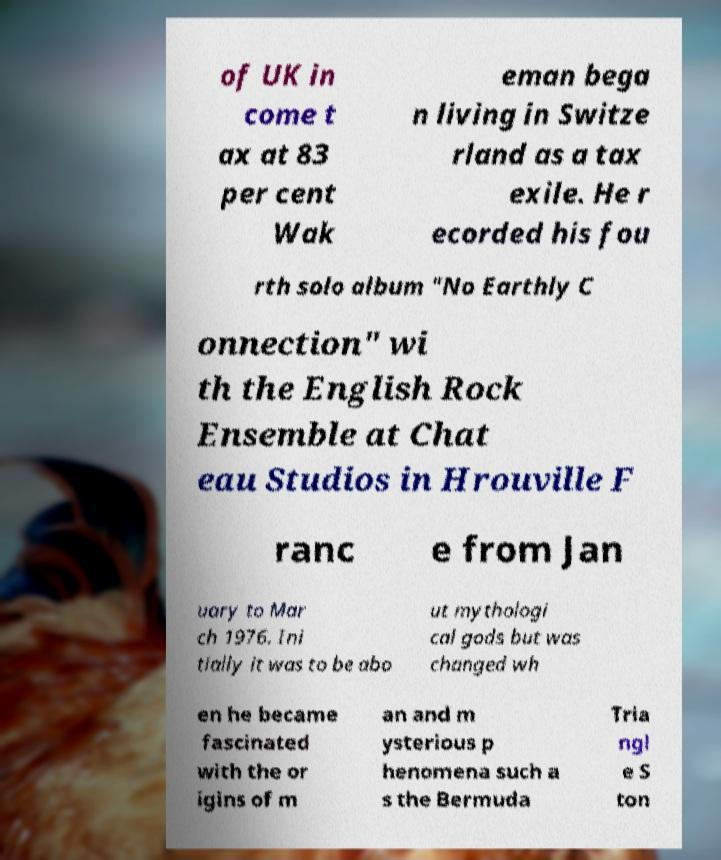What messages or text are displayed in this image? I need them in a readable, typed format. of UK in come t ax at 83 per cent Wak eman bega n living in Switze rland as a tax exile. He r ecorded his fou rth solo album "No Earthly C onnection" wi th the English Rock Ensemble at Chat eau Studios in Hrouville F ranc e from Jan uary to Mar ch 1976. Ini tially it was to be abo ut mythologi cal gods but was changed wh en he became fascinated with the or igins of m an and m ysterious p henomena such a s the Bermuda Tria ngl e S ton 